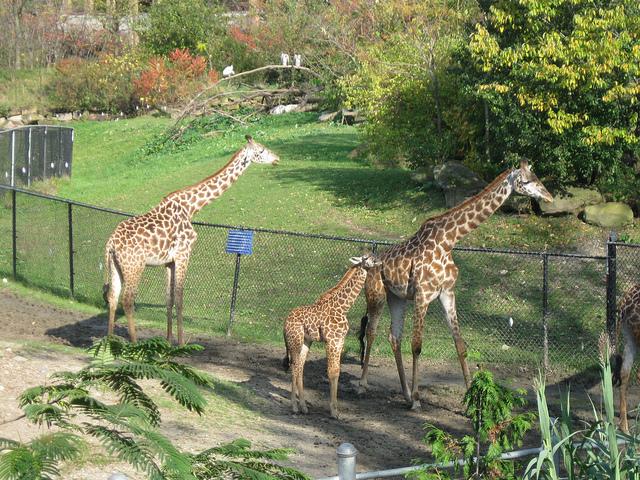Are the giraffes in the wild?
Quick response, please. No. Are the giraffes in their natural habitat?
Be succinct. No. How many baby giraffes are in the picture?
Give a very brief answer. 1. 